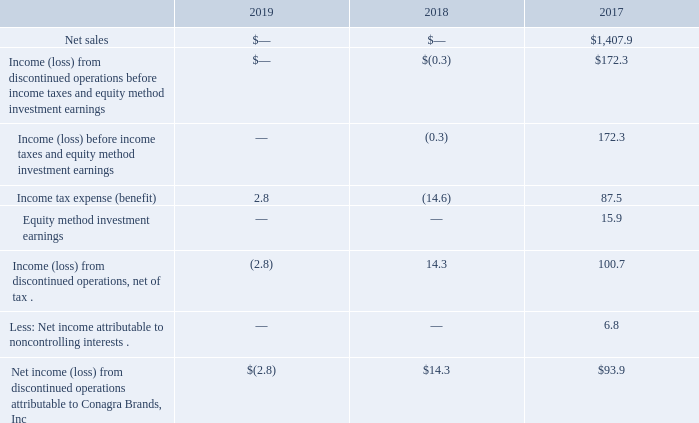Notes to Consolidated Financial Statements - (Continued) Fiscal Years Ended May 26, 2019, May 27, 2018, and May 28, 2017 (columnar dollars in millions except per share amounts) Lamb Weston Spinoff
On November 9, 2016, we completed the Spinoff of our Lamb Weston business. As of such date, we did not beneficially own any equity interest in Lamb Weston and no longer consolidated Lamb Weston into our financial results. The business results were previously reported in the Commercial segment. We reflected the results of this business as discontinued operations for all periods presented.
The summary comparative financial results of the Lamb Weston business through the date of the Spinoff, included within discontinued operations, were as follows:
During fiscal 2017, we incurred $74.8 million of expenses in connection with the Spinoff primarily related to professional fees and contract services associated with preparation of regulatory filings and separation activities. These expenses are reflected in income from discontinued operations. During fiscal 2019 and 2018, we recognized income tax expense of $2.8 million and an income tax benefit of $14.5 million, respectively, due to adjustments of the estimated deductibility of these costs.
In connection with the Spinoff, total assets of $2.28 billion and total liabilities of $2.98 billion (including debt of $2.46 billion) were transferred to Lamb Weston. As part of the consideration for the Spinoff, the Company received a cash payment from Lamb Weston in the amount of $823.5 million. See Note 4 for discussion of the debt-for-debt exchange related to the Spinoff.
We entered into a transition services agreement in connection with the Lamb Weston Spinoff and recognized $2.2 million and $4.2 million of income for the performance of services during fiscal 2018 and 2017, respectively, classified within SG&A expenses.
What did expenses in connection with the Spinoff primarily relate to in the fiscal year 2017? Professional fees and contract services associated with preparation of regulatory filings and separation activities. How many assets and liabilities concerning the Spinoff were transferred to Lamb Weston respectively? $2.28 billion, $2.98 billion. What was the net sales (in millions) in 2017? $1,407.9. What is the net profit margin in 2017? 93.9/1,407.9 
Answer: 0.07. What is the percentage change in net income (loss) from discontinued operations attributable to Conagra Brands, Inc. from 2017 to 2018?
Answer scale should be: percent. (14.3-93.9)/93.9 
Answer: -84.77. What is the proportion (in percentage) of income tax benefit due to adjustment of the estimated deductibility of professional fees and contract services over income tax benefit in 2018?
Answer scale should be: percent. 14.5/14.6 
Answer: 99.32. 